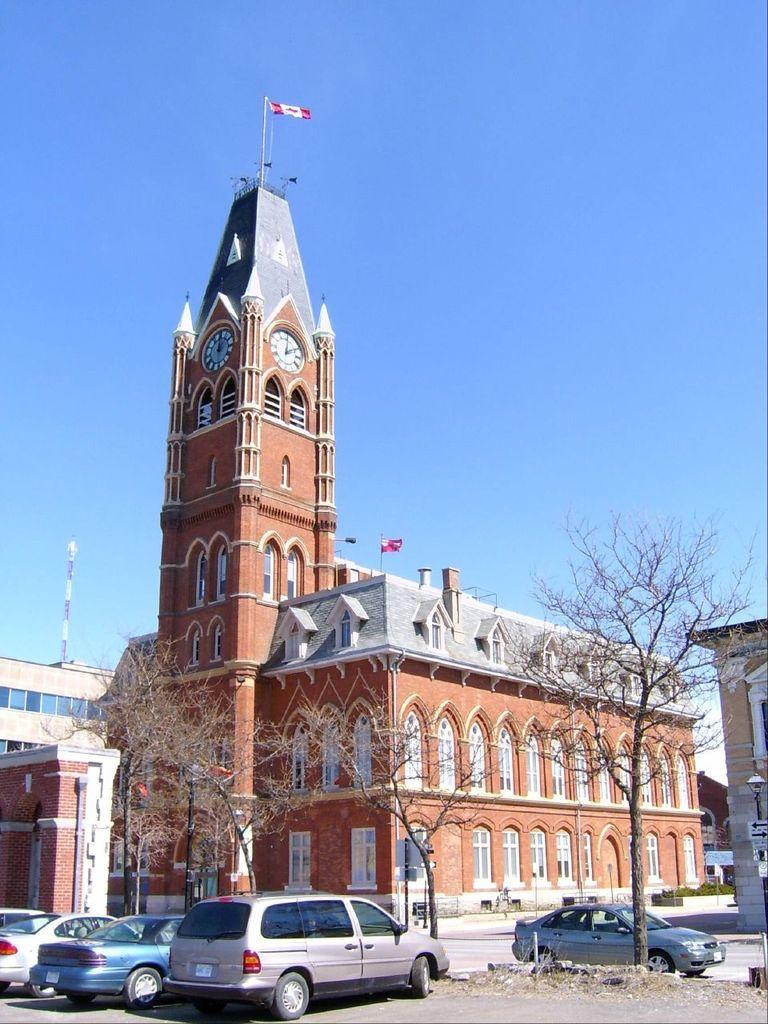What type of structures can be seen in the image? There are buildings in the image. What else can be seen on the ground in the image? Cars are visible on the road at the bottom of the image. What type of vegetation is present in the image? There are trees in the image. What is visible in the background of the image? The sky is visible in the background of the image. How many beans are growing on the trees in the image? There are no beans present in the image, as it features trees rather than plants that produce beans. 